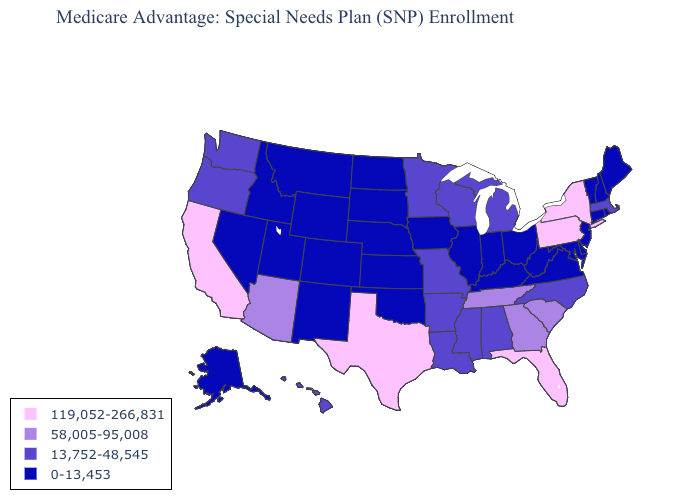Name the states that have a value in the range 58,005-95,008?
Give a very brief answer. Arizona, Georgia, South Carolina, Tennessee. Name the states that have a value in the range 0-13,453?
Concise answer only. Alaska, Colorado, Connecticut, Delaware, Iowa, Idaho, Illinois, Indiana, Kansas, Kentucky, Maryland, Maine, Montana, North Dakota, Nebraska, New Hampshire, New Jersey, New Mexico, Nevada, Ohio, Oklahoma, Rhode Island, South Dakota, Utah, Virginia, Vermont, West Virginia, Wyoming. Which states have the lowest value in the Northeast?
Keep it brief. Connecticut, Maine, New Hampshire, New Jersey, Rhode Island, Vermont. Does Pennsylvania have a higher value than Texas?
Quick response, please. No. Does New Mexico have the lowest value in the West?
Concise answer only. Yes. Among the states that border Virginia , which have the lowest value?
Quick response, please. Kentucky, Maryland, West Virginia. Among the states that border Louisiana , which have the lowest value?
Keep it brief. Arkansas, Mississippi. Is the legend a continuous bar?
Quick response, please. No. Does New York have the lowest value in the Northeast?
Short answer required. No. What is the value of South Dakota?
Quick response, please. 0-13,453. Name the states that have a value in the range 58,005-95,008?
Short answer required. Arizona, Georgia, South Carolina, Tennessee. What is the value of Wisconsin?
Give a very brief answer. 13,752-48,545. What is the value of New Mexico?
Write a very short answer. 0-13,453. Among the states that border Nevada , does California have the lowest value?
Answer briefly. No. What is the value of South Carolina?
Short answer required. 58,005-95,008. 